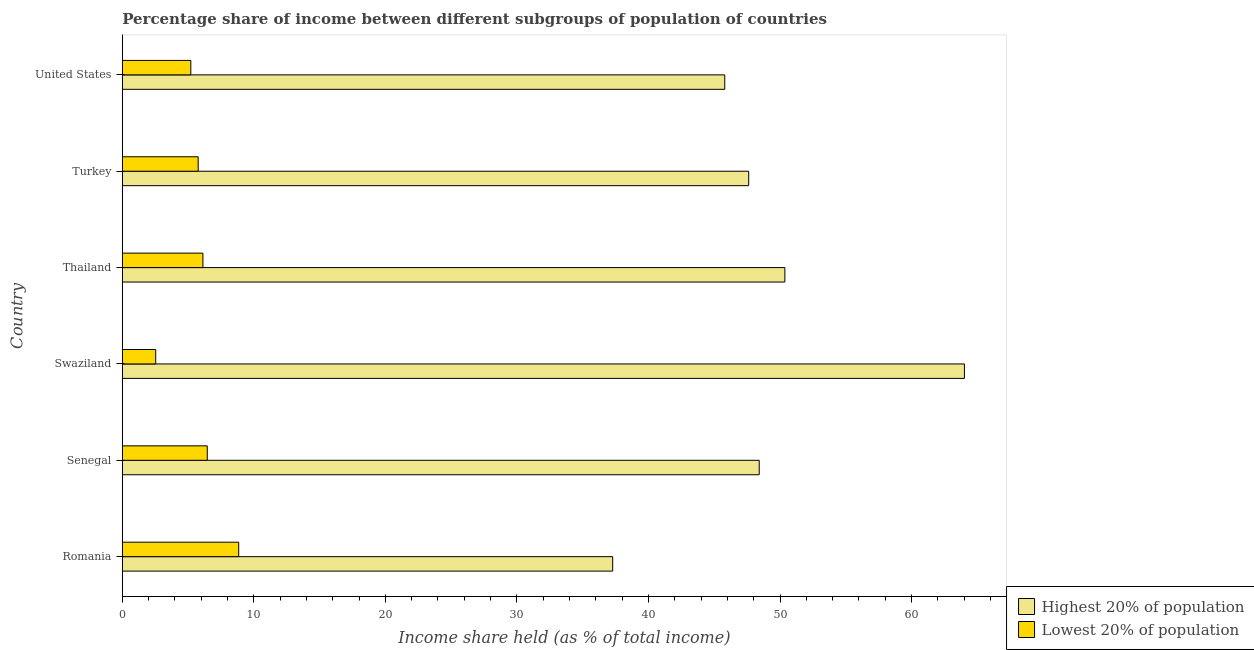How many different coloured bars are there?
Your answer should be compact. 2. Are the number of bars on each tick of the Y-axis equal?
Provide a short and direct response. Yes. What is the label of the 5th group of bars from the top?
Offer a very short reply. Senegal. In how many cases, is the number of bars for a given country not equal to the number of legend labels?
Give a very brief answer. 0. What is the income share held by highest 20% of the population in Swaziland?
Offer a very short reply. 64.02. Across all countries, what is the maximum income share held by lowest 20% of the population?
Your answer should be compact. 8.85. Across all countries, what is the minimum income share held by lowest 20% of the population?
Ensure brevity in your answer.  2.54. In which country was the income share held by highest 20% of the population maximum?
Your response must be concise. Swaziland. In which country was the income share held by highest 20% of the population minimum?
Offer a terse response. Romania. What is the total income share held by highest 20% of the population in the graph?
Make the answer very short. 293.51. What is the difference between the income share held by lowest 20% of the population in Thailand and that in Turkey?
Your answer should be very brief. 0.36. What is the difference between the income share held by highest 20% of the population in Turkey and the income share held by lowest 20% of the population in United States?
Your answer should be compact. 42.41. What is the average income share held by highest 20% of the population per country?
Your answer should be very brief. 48.92. What is the difference between the income share held by highest 20% of the population and income share held by lowest 20% of the population in Romania?
Provide a short and direct response. 28.43. In how many countries, is the income share held by lowest 20% of the population greater than 14 %?
Your answer should be compact. 0. What is the ratio of the income share held by lowest 20% of the population in Romania to that in Swaziland?
Offer a very short reply. 3.48. What is the difference between the highest and the second highest income share held by highest 20% of the population?
Give a very brief answer. 13.65. What is the difference between the highest and the lowest income share held by highest 20% of the population?
Your answer should be compact. 26.74. Is the sum of the income share held by lowest 20% of the population in Thailand and United States greater than the maximum income share held by highest 20% of the population across all countries?
Keep it short and to the point. No. What does the 2nd bar from the top in Romania represents?
Make the answer very short. Highest 20% of population. What does the 2nd bar from the bottom in Thailand represents?
Your answer should be very brief. Lowest 20% of population. How many bars are there?
Offer a very short reply. 12. Where does the legend appear in the graph?
Your answer should be compact. Bottom right. How many legend labels are there?
Ensure brevity in your answer.  2. How are the legend labels stacked?
Offer a terse response. Vertical. What is the title of the graph?
Your answer should be very brief. Percentage share of income between different subgroups of population of countries. Does "By country of origin" appear as one of the legend labels in the graph?
Give a very brief answer. No. What is the label or title of the X-axis?
Keep it short and to the point. Income share held (as % of total income). What is the label or title of the Y-axis?
Keep it short and to the point. Country. What is the Income share held (as % of total income) in Highest 20% of population in Romania?
Offer a very short reply. 37.28. What is the Income share held (as % of total income) in Lowest 20% of population in Romania?
Ensure brevity in your answer.  8.85. What is the Income share held (as % of total income) of Highest 20% of population in Senegal?
Ensure brevity in your answer.  48.42. What is the Income share held (as % of total income) in Lowest 20% of population in Senegal?
Make the answer very short. 6.46. What is the Income share held (as % of total income) of Highest 20% of population in Swaziland?
Your response must be concise. 64.02. What is the Income share held (as % of total income) in Lowest 20% of population in Swaziland?
Give a very brief answer. 2.54. What is the Income share held (as % of total income) of Highest 20% of population in Thailand?
Provide a short and direct response. 50.37. What is the Income share held (as % of total income) of Lowest 20% of population in Thailand?
Keep it short and to the point. 6.13. What is the Income share held (as % of total income) of Highest 20% of population in Turkey?
Give a very brief answer. 47.62. What is the Income share held (as % of total income) of Lowest 20% of population in Turkey?
Make the answer very short. 5.77. What is the Income share held (as % of total income) of Highest 20% of population in United States?
Provide a succinct answer. 45.8. What is the Income share held (as % of total income) in Lowest 20% of population in United States?
Keep it short and to the point. 5.21. Across all countries, what is the maximum Income share held (as % of total income) of Highest 20% of population?
Your answer should be very brief. 64.02. Across all countries, what is the maximum Income share held (as % of total income) of Lowest 20% of population?
Your answer should be very brief. 8.85. Across all countries, what is the minimum Income share held (as % of total income) in Highest 20% of population?
Keep it short and to the point. 37.28. Across all countries, what is the minimum Income share held (as % of total income) in Lowest 20% of population?
Provide a succinct answer. 2.54. What is the total Income share held (as % of total income) of Highest 20% of population in the graph?
Provide a succinct answer. 293.51. What is the total Income share held (as % of total income) of Lowest 20% of population in the graph?
Provide a succinct answer. 34.96. What is the difference between the Income share held (as % of total income) of Highest 20% of population in Romania and that in Senegal?
Your response must be concise. -11.14. What is the difference between the Income share held (as % of total income) in Lowest 20% of population in Romania and that in Senegal?
Offer a terse response. 2.39. What is the difference between the Income share held (as % of total income) in Highest 20% of population in Romania and that in Swaziland?
Your answer should be very brief. -26.74. What is the difference between the Income share held (as % of total income) of Lowest 20% of population in Romania and that in Swaziland?
Your response must be concise. 6.31. What is the difference between the Income share held (as % of total income) of Highest 20% of population in Romania and that in Thailand?
Provide a short and direct response. -13.09. What is the difference between the Income share held (as % of total income) in Lowest 20% of population in Romania and that in Thailand?
Provide a short and direct response. 2.72. What is the difference between the Income share held (as % of total income) in Highest 20% of population in Romania and that in Turkey?
Keep it short and to the point. -10.34. What is the difference between the Income share held (as % of total income) in Lowest 20% of population in Romania and that in Turkey?
Give a very brief answer. 3.08. What is the difference between the Income share held (as % of total income) of Highest 20% of population in Romania and that in United States?
Provide a short and direct response. -8.52. What is the difference between the Income share held (as % of total income) of Lowest 20% of population in Romania and that in United States?
Provide a short and direct response. 3.64. What is the difference between the Income share held (as % of total income) of Highest 20% of population in Senegal and that in Swaziland?
Offer a very short reply. -15.6. What is the difference between the Income share held (as % of total income) in Lowest 20% of population in Senegal and that in Swaziland?
Keep it short and to the point. 3.92. What is the difference between the Income share held (as % of total income) in Highest 20% of population in Senegal and that in Thailand?
Offer a very short reply. -1.95. What is the difference between the Income share held (as % of total income) of Lowest 20% of population in Senegal and that in Thailand?
Keep it short and to the point. 0.33. What is the difference between the Income share held (as % of total income) in Highest 20% of population in Senegal and that in Turkey?
Make the answer very short. 0.8. What is the difference between the Income share held (as % of total income) of Lowest 20% of population in Senegal and that in Turkey?
Your answer should be compact. 0.69. What is the difference between the Income share held (as % of total income) of Highest 20% of population in Senegal and that in United States?
Keep it short and to the point. 2.62. What is the difference between the Income share held (as % of total income) in Lowest 20% of population in Senegal and that in United States?
Provide a succinct answer. 1.25. What is the difference between the Income share held (as % of total income) of Highest 20% of population in Swaziland and that in Thailand?
Your answer should be compact. 13.65. What is the difference between the Income share held (as % of total income) in Lowest 20% of population in Swaziland and that in Thailand?
Offer a very short reply. -3.59. What is the difference between the Income share held (as % of total income) of Lowest 20% of population in Swaziland and that in Turkey?
Your answer should be very brief. -3.23. What is the difference between the Income share held (as % of total income) in Highest 20% of population in Swaziland and that in United States?
Provide a succinct answer. 18.22. What is the difference between the Income share held (as % of total income) in Lowest 20% of population in Swaziland and that in United States?
Your answer should be compact. -2.67. What is the difference between the Income share held (as % of total income) in Highest 20% of population in Thailand and that in Turkey?
Make the answer very short. 2.75. What is the difference between the Income share held (as % of total income) of Lowest 20% of population in Thailand and that in Turkey?
Provide a short and direct response. 0.36. What is the difference between the Income share held (as % of total income) of Highest 20% of population in Thailand and that in United States?
Offer a very short reply. 4.57. What is the difference between the Income share held (as % of total income) of Highest 20% of population in Turkey and that in United States?
Give a very brief answer. 1.82. What is the difference between the Income share held (as % of total income) of Lowest 20% of population in Turkey and that in United States?
Make the answer very short. 0.56. What is the difference between the Income share held (as % of total income) of Highest 20% of population in Romania and the Income share held (as % of total income) of Lowest 20% of population in Senegal?
Your answer should be very brief. 30.82. What is the difference between the Income share held (as % of total income) of Highest 20% of population in Romania and the Income share held (as % of total income) of Lowest 20% of population in Swaziland?
Provide a short and direct response. 34.74. What is the difference between the Income share held (as % of total income) in Highest 20% of population in Romania and the Income share held (as % of total income) in Lowest 20% of population in Thailand?
Give a very brief answer. 31.15. What is the difference between the Income share held (as % of total income) of Highest 20% of population in Romania and the Income share held (as % of total income) of Lowest 20% of population in Turkey?
Ensure brevity in your answer.  31.51. What is the difference between the Income share held (as % of total income) of Highest 20% of population in Romania and the Income share held (as % of total income) of Lowest 20% of population in United States?
Provide a succinct answer. 32.07. What is the difference between the Income share held (as % of total income) in Highest 20% of population in Senegal and the Income share held (as % of total income) in Lowest 20% of population in Swaziland?
Ensure brevity in your answer.  45.88. What is the difference between the Income share held (as % of total income) in Highest 20% of population in Senegal and the Income share held (as % of total income) in Lowest 20% of population in Thailand?
Your answer should be compact. 42.29. What is the difference between the Income share held (as % of total income) of Highest 20% of population in Senegal and the Income share held (as % of total income) of Lowest 20% of population in Turkey?
Offer a very short reply. 42.65. What is the difference between the Income share held (as % of total income) of Highest 20% of population in Senegal and the Income share held (as % of total income) of Lowest 20% of population in United States?
Ensure brevity in your answer.  43.21. What is the difference between the Income share held (as % of total income) in Highest 20% of population in Swaziland and the Income share held (as % of total income) in Lowest 20% of population in Thailand?
Make the answer very short. 57.89. What is the difference between the Income share held (as % of total income) of Highest 20% of population in Swaziland and the Income share held (as % of total income) of Lowest 20% of population in Turkey?
Ensure brevity in your answer.  58.25. What is the difference between the Income share held (as % of total income) of Highest 20% of population in Swaziland and the Income share held (as % of total income) of Lowest 20% of population in United States?
Provide a succinct answer. 58.81. What is the difference between the Income share held (as % of total income) in Highest 20% of population in Thailand and the Income share held (as % of total income) in Lowest 20% of population in Turkey?
Ensure brevity in your answer.  44.6. What is the difference between the Income share held (as % of total income) in Highest 20% of population in Thailand and the Income share held (as % of total income) in Lowest 20% of population in United States?
Make the answer very short. 45.16. What is the difference between the Income share held (as % of total income) of Highest 20% of population in Turkey and the Income share held (as % of total income) of Lowest 20% of population in United States?
Offer a terse response. 42.41. What is the average Income share held (as % of total income) in Highest 20% of population per country?
Keep it short and to the point. 48.92. What is the average Income share held (as % of total income) in Lowest 20% of population per country?
Offer a terse response. 5.83. What is the difference between the Income share held (as % of total income) of Highest 20% of population and Income share held (as % of total income) of Lowest 20% of population in Romania?
Give a very brief answer. 28.43. What is the difference between the Income share held (as % of total income) in Highest 20% of population and Income share held (as % of total income) in Lowest 20% of population in Senegal?
Offer a very short reply. 41.96. What is the difference between the Income share held (as % of total income) of Highest 20% of population and Income share held (as % of total income) of Lowest 20% of population in Swaziland?
Your response must be concise. 61.48. What is the difference between the Income share held (as % of total income) in Highest 20% of population and Income share held (as % of total income) in Lowest 20% of population in Thailand?
Your answer should be very brief. 44.24. What is the difference between the Income share held (as % of total income) of Highest 20% of population and Income share held (as % of total income) of Lowest 20% of population in Turkey?
Your response must be concise. 41.85. What is the difference between the Income share held (as % of total income) of Highest 20% of population and Income share held (as % of total income) of Lowest 20% of population in United States?
Make the answer very short. 40.59. What is the ratio of the Income share held (as % of total income) of Highest 20% of population in Romania to that in Senegal?
Give a very brief answer. 0.77. What is the ratio of the Income share held (as % of total income) in Lowest 20% of population in Romania to that in Senegal?
Your response must be concise. 1.37. What is the ratio of the Income share held (as % of total income) in Highest 20% of population in Romania to that in Swaziland?
Your answer should be compact. 0.58. What is the ratio of the Income share held (as % of total income) of Lowest 20% of population in Romania to that in Swaziland?
Make the answer very short. 3.48. What is the ratio of the Income share held (as % of total income) in Highest 20% of population in Romania to that in Thailand?
Provide a succinct answer. 0.74. What is the ratio of the Income share held (as % of total income) of Lowest 20% of population in Romania to that in Thailand?
Make the answer very short. 1.44. What is the ratio of the Income share held (as % of total income) in Highest 20% of population in Romania to that in Turkey?
Provide a succinct answer. 0.78. What is the ratio of the Income share held (as % of total income) of Lowest 20% of population in Romania to that in Turkey?
Keep it short and to the point. 1.53. What is the ratio of the Income share held (as % of total income) in Highest 20% of population in Romania to that in United States?
Offer a very short reply. 0.81. What is the ratio of the Income share held (as % of total income) of Lowest 20% of population in Romania to that in United States?
Give a very brief answer. 1.7. What is the ratio of the Income share held (as % of total income) of Highest 20% of population in Senegal to that in Swaziland?
Your answer should be very brief. 0.76. What is the ratio of the Income share held (as % of total income) in Lowest 20% of population in Senegal to that in Swaziland?
Provide a succinct answer. 2.54. What is the ratio of the Income share held (as % of total income) of Highest 20% of population in Senegal to that in Thailand?
Keep it short and to the point. 0.96. What is the ratio of the Income share held (as % of total income) of Lowest 20% of population in Senegal to that in Thailand?
Ensure brevity in your answer.  1.05. What is the ratio of the Income share held (as % of total income) in Highest 20% of population in Senegal to that in Turkey?
Provide a short and direct response. 1.02. What is the ratio of the Income share held (as % of total income) in Lowest 20% of population in Senegal to that in Turkey?
Give a very brief answer. 1.12. What is the ratio of the Income share held (as % of total income) in Highest 20% of population in Senegal to that in United States?
Offer a very short reply. 1.06. What is the ratio of the Income share held (as % of total income) of Lowest 20% of population in Senegal to that in United States?
Make the answer very short. 1.24. What is the ratio of the Income share held (as % of total income) in Highest 20% of population in Swaziland to that in Thailand?
Provide a short and direct response. 1.27. What is the ratio of the Income share held (as % of total income) in Lowest 20% of population in Swaziland to that in Thailand?
Ensure brevity in your answer.  0.41. What is the ratio of the Income share held (as % of total income) in Highest 20% of population in Swaziland to that in Turkey?
Your answer should be compact. 1.34. What is the ratio of the Income share held (as % of total income) of Lowest 20% of population in Swaziland to that in Turkey?
Your answer should be compact. 0.44. What is the ratio of the Income share held (as % of total income) in Highest 20% of population in Swaziland to that in United States?
Your answer should be very brief. 1.4. What is the ratio of the Income share held (as % of total income) in Lowest 20% of population in Swaziland to that in United States?
Make the answer very short. 0.49. What is the ratio of the Income share held (as % of total income) in Highest 20% of population in Thailand to that in Turkey?
Provide a short and direct response. 1.06. What is the ratio of the Income share held (as % of total income) in Lowest 20% of population in Thailand to that in Turkey?
Ensure brevity in your answer.  1.06. What is the ratio of the Income share held (as % of total income) in Highest 20% of population in Thailand to that in United States?
Offer a very short reply. 1.1. What is the ratio of the Income share held (as % of total income) in Lowest 20% of population in Thailand to that in United States?
Offer a very short reply. 1.18. What is the ratio of the Income share held (as % of total income) in Highest 20% of population in Turkey to that in United States?
Provide a short and direct response. 1.04. What is the ratio of the Income share held (as % of total income) in Lowest 20% of population in Turkey to that in United States?
Ensure brevity in your answer.  1.11. What is the difference between the highest and the second highest Income share held (as % of total income) in Highest 20% of population?
Offer a very short reply. 13.65. What is the difference between the highest and the second highest Income share held (as % of total income) in Lowest 20% of population?
Provide a succinct answer. 2.39. What is the difference between the highest and the lowest Income share held (as % of total income) in Highest 20% of population?
Ensure brevity in your answer.  26.74. What is the difference between the highest and the lowest Income share held (as % of total income) in Lowest 20% of population?
Ensure brevity in your answer.  6.31. 